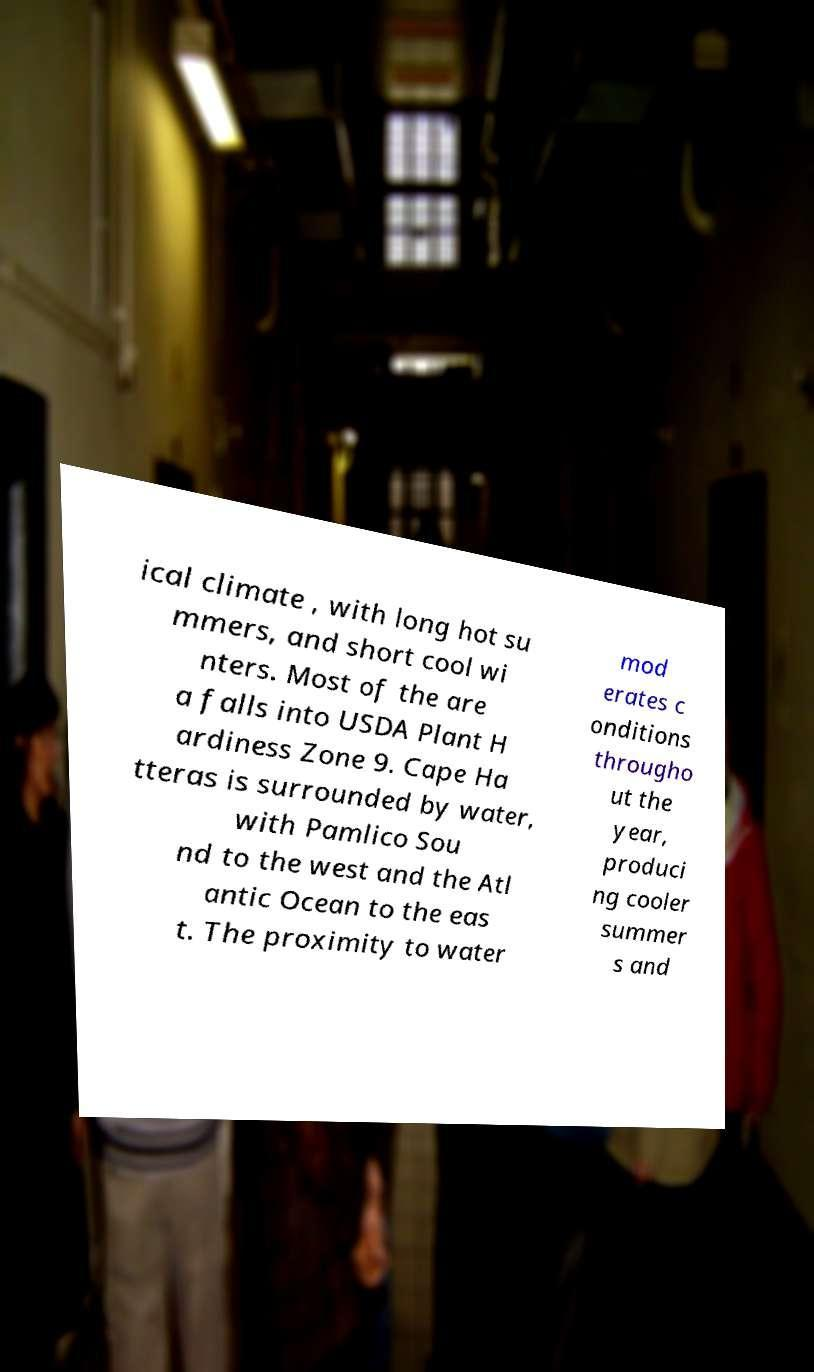Could you assist in decoding the text presented in this image and type it out clearly? ical climate , with long hot su mmers, and short cool wi nters. Most of the are a falls into USDA Plant H ardiness Zone 9. Cape Ha tteras is surrounded by water, with Pamlico Sou nd to the west and the Atl antic Ocean to the eas t. The proximity to water mod erates c onditions througho ut the year, produci ng cooler summer s and 